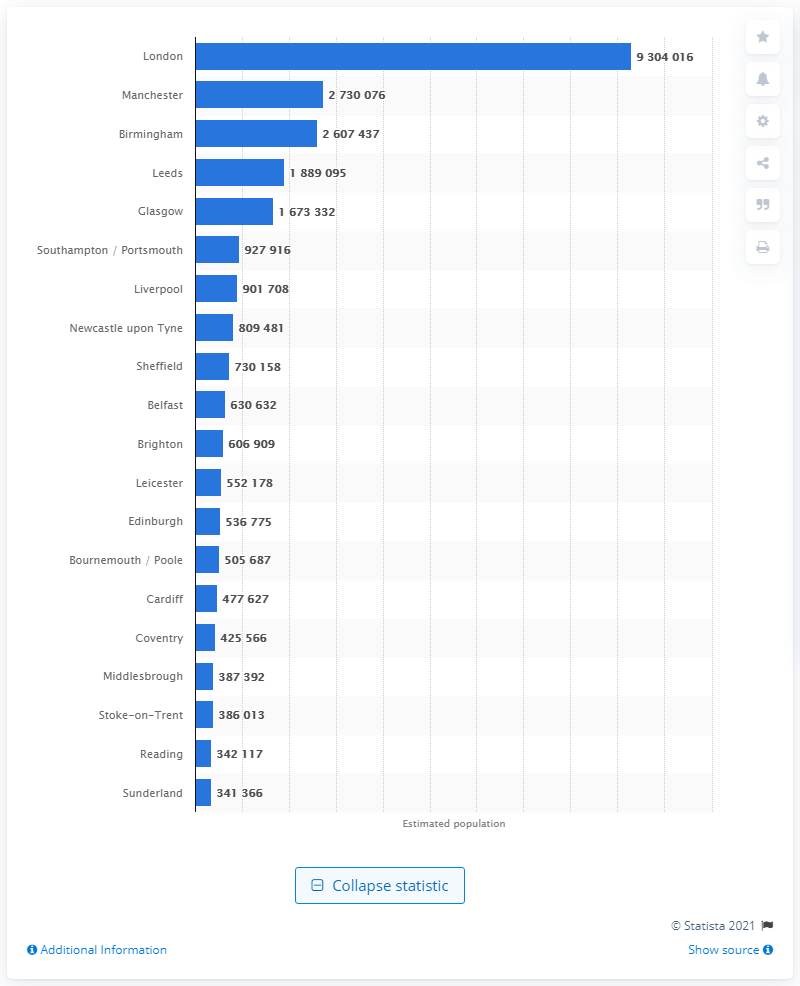Specify some key components in this picture. As of 2020, it is estimated that the population of London was approximately 9,304,016 people. Glasgow is the largest city in Scotland. 